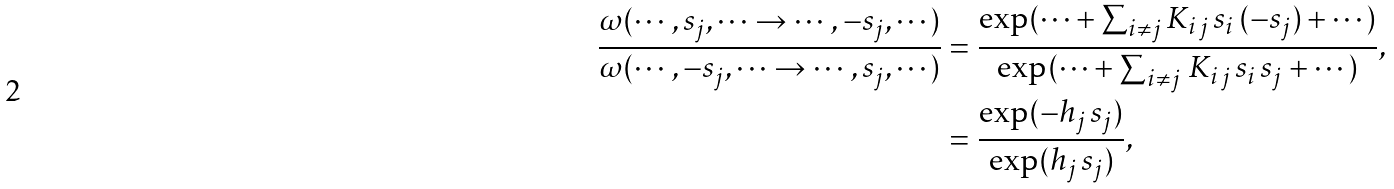Convert formula to latex. <formula><loc_0><loc_0><loc_500><loc_500>\frac { \omega ( \cdots , s _ { j } , \cdots \to \cdots , - s _ { j } , \cdots ) } { \omega ( \cdots , - s _ { j } , \cdots \to \cdots , s _ { j } , \cdots ) } & = \frac { \exp ( \cdots + \sum _ { i \ne j } K _ { i \, j } \, s _ { i } \, ( - s _ { j } ) + \cdots ) } { \exp ( \cdots + \sum _ { i \ne j } \, K _ { i \, j } \, s _ { i } \, s _ { j } + \cdots ) } , \\ & = \frac { \exp ( - h _ { j } \, s _ { j } ) } { \exp ( h _ { j } \, s _ { j } ) } ,</formula> 